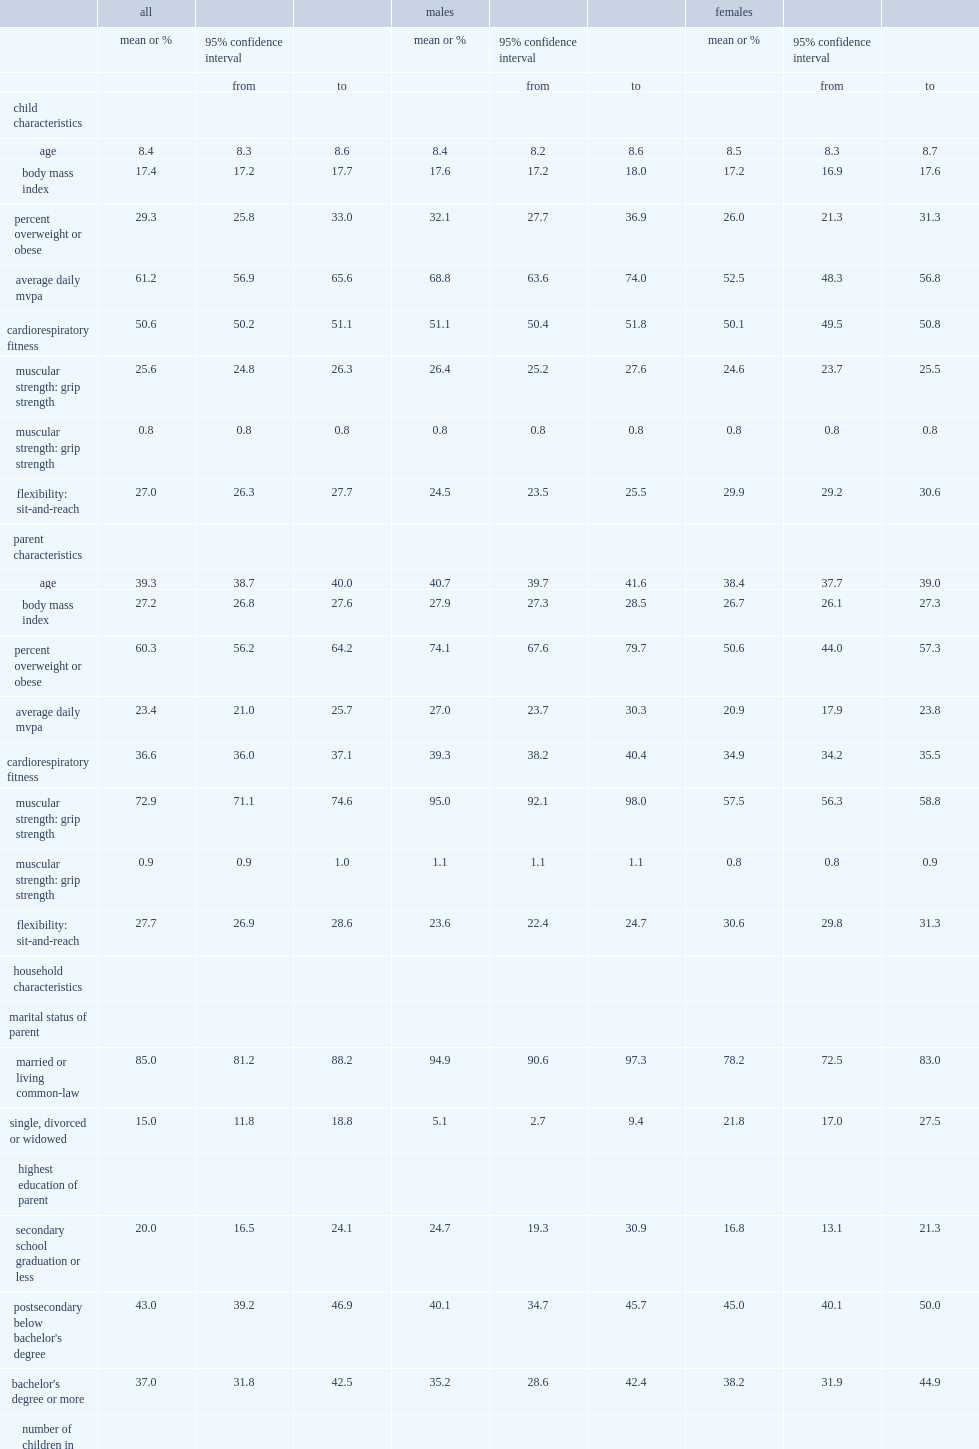Parents of which sex were younger on average? Females. Parents of which sex were less likely to be married or common law? Females. Children of which sex had higher average daily minutes of mvpa? Males. Children of which sex had higher muscular strength? Males. Adults of which sex had higher average daily minutes of mvpa? Males. Adults of which sex had higher bmi? Males. Adults of which sex had higher crf? Males. Adults of which sex had higher grip strength? Males. Children of which sex had higher flexibility? Females. Adults of which sex had higher flexibility? Females. 